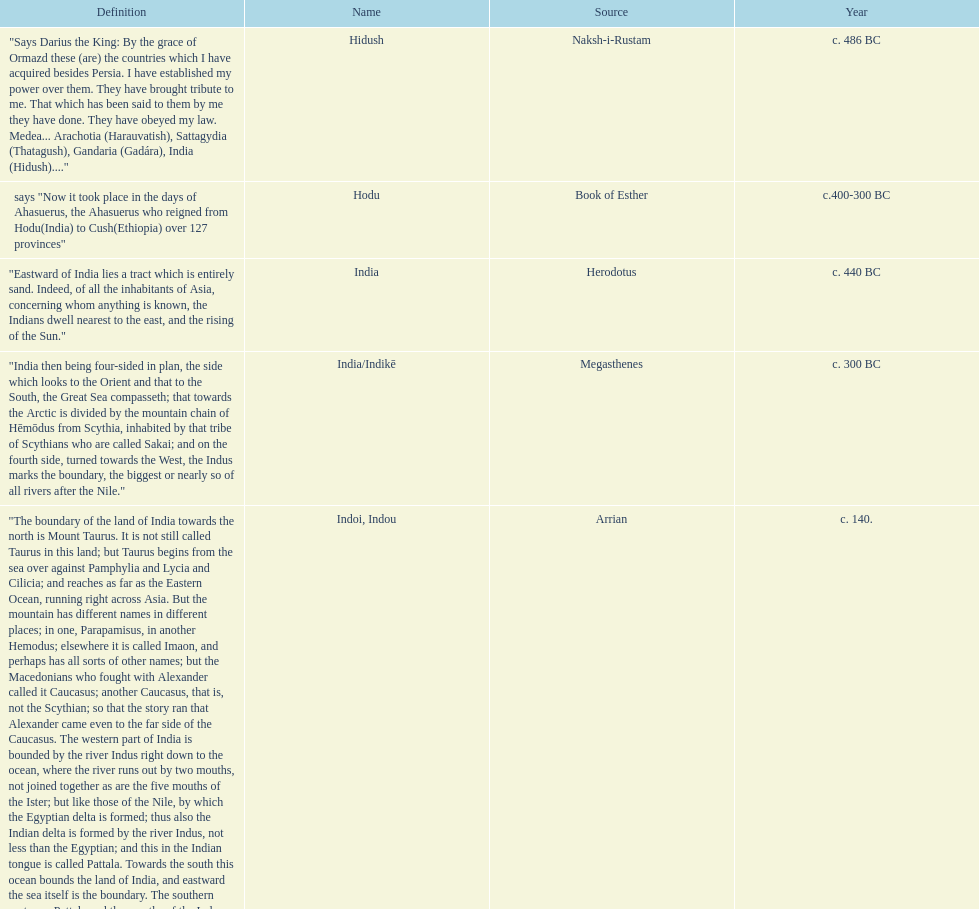What was the nation called before the book of esther called it hodu? Hidush. 